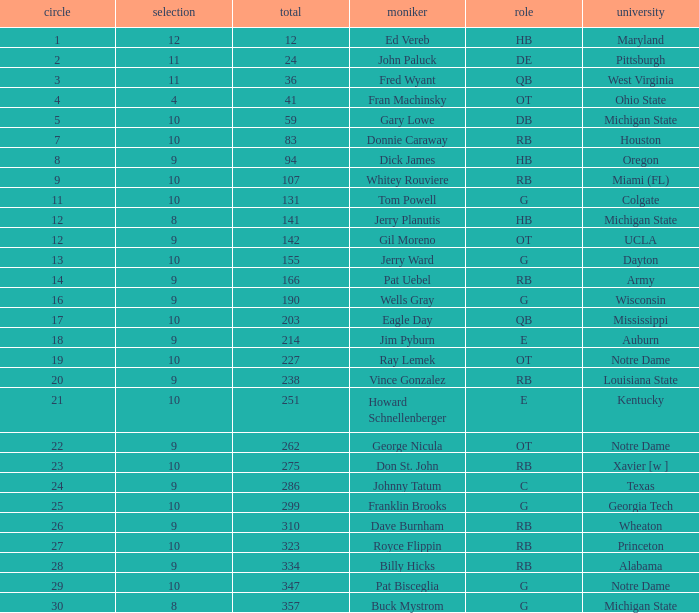What is the average number of rounds for billy hicks who had an overall pick number bigger than 310? 28.0. 